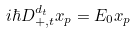<formula> <loc_0><loc_0><loc_500><loc_500>i \hbar { D } _ { + , t } ^ { d _ { t } } x _ { p } = E _ { 0 } x _ { p }</formula> 